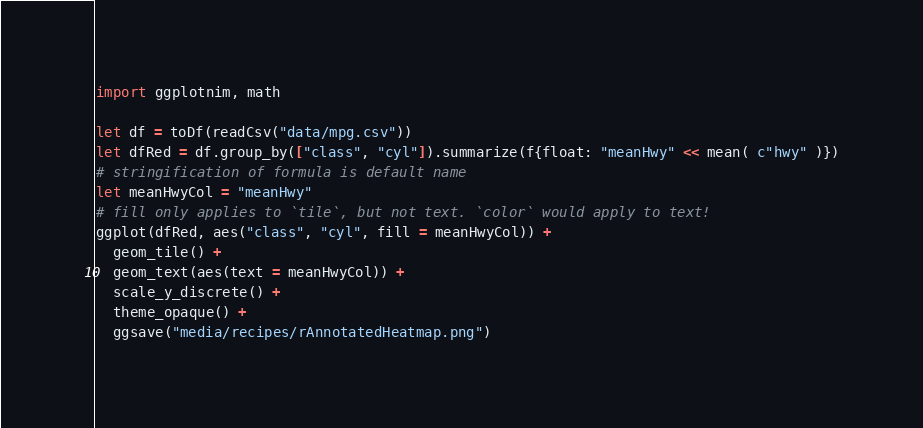Convert code to text. <code><loc_0><loc_0><loc_500><loc_500><_Nim_>import ggplotnim, math

let df = toDf(readCsv("data/mpg.csv"))
let dfRed = df.group_by(["class", "cyl"]).summarize(f{float: "meanHwy" << mean( c"hwy" )})
# stringification of formula is default name
let meanHwyCol = "meanHwy"
# fill only applies to `tile`, but not text. `color` would apply to text!
ggplot(dfRed, aes("class", "cyl", fill = meanHwyCol)) +
  geom_tile() +
  geom_text(aes(text = meanHwyCol)) +
  scale_y_discrete() +
  theme_opaque() +
  ggsave("media/recipes/rAnnotatedHeatmap.png")
</code> 